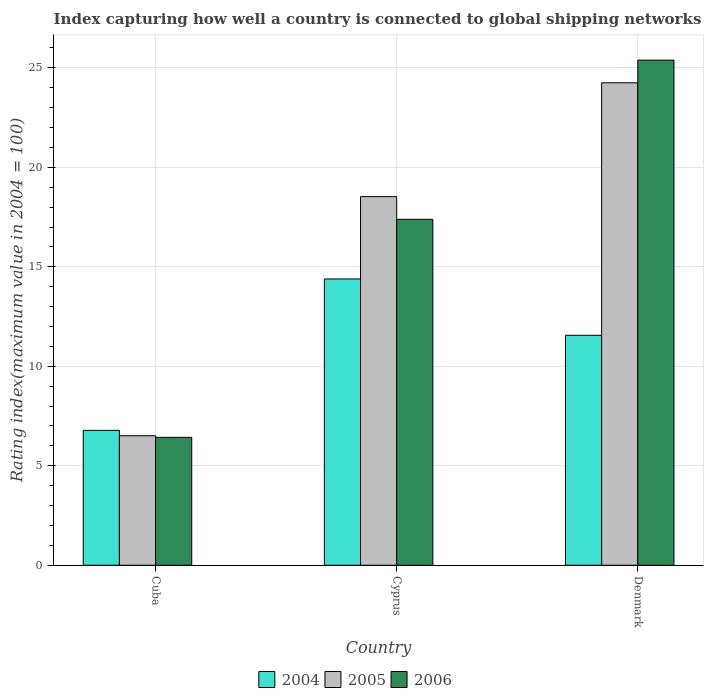How many groups of bars are there?
Provide a short and direct response. 3. How many bars are there on the 3rd tick from the left?
Give a very brief answer. 3. What is the label of the 2nd group of bars from the left?
Make the answer very short. Cyprus. What is the rating index in 2004 in Denmark?
Make the answer very short. 11.56. Across all countries, what is the maximum rating index in 2004?
Keep it short and to the point. 14.39. Across all countries, what is the minimum rating index in 2004?
Ensure brevity in your answer.  6.78. In which country was the rating index in 2006 minimum?
Give a very brief answer. Cuba. What is the total rating index in 2006 in the graph?
Your answer should be very brief. 49.21. What is the difference between the rating index in 2005 in Cuba and that in Cyprus?
Provide a succinct answer. -12.02. What is the difference between the rating index in 2006 in Cuba and the rating index in 2005 in Cyprus?
Your response must be concise. -12.1. What is the average rating index in 2005 per country?
Offer a terse response. 16.43. What is the difference between the rating index of/in 2004 and rating index of/in 2006 in Cuba?
Your answer should be very brief. 0.35. What is the ratio of the rating index in 2004 in Cuba to that in Denmark?
Make the answer very short. 0.59. Is the difference between the rating index in 2004 in Cyprus and Denmark greater than the difference between the rating index in 2006 in Cyprus and Denmark?
Keep it short and to the point. Yes. What is the difference between the highest and the second highest rating index in 2005?
Ensure brevity in your answer.  5.72. What is the difference between the highest and the lowest rating index in 2006?
Offer a very short reply. 18.96. In how many countries, is the rating index in 2006 greater than the average rating index in 2006 taken over all countries?
Ensure brevity in your answer.  2. Is the sum of the rating index in 2004 in Cuba and Denmark greater than the maximum rating index in 2006 across all countries?
Your answer should be very brief. No. What does the 1st bar from the right in Denmark represents?
Make the answer very short. 2006. How many bars are there?
Offer a terse response. 9. Are the values on the major ticks of Y-axis written in scientific E-notation?
Keep it short and to the point. No. Does the graph contain any zero values?
Ensure brevity in your answer.  No. Does the graph contain grids?
Give a very brief answer. Yes. Where does the legend appear in the graph?
Provide a succinct answer. Bottom center. How many legend labels are there?
Your response must be concise. 3. How are the legend labels stacked?
Make the answer very short. Horizontal. What is the title of the graph?
Your response must be concise. Index capturing how well a country is connected to global shipping networks. Does "1963" appear as one of the legend labels in the graph?
Make the answer very short. No. What is the label or title of the X-axis?
Your response must be concise. Country. What is the label or title of the Y-axis?
Make the answer very short. Rating index(maximum value in 2004 = 100). What is the Rating index(maximum value in 2004 = 100) in 2004 in Cuba?
Your answer should be very brief. 6.78. What is the Rating index(maximum value in 2004 = 100) in 2005 in Cuba?
Offer a terse response. 6.51. What is the Rating index(maximum value in 2004 = 100) of 2006 in Cuba?
Your answer should be very brief. 6.43. What is the Rating index(maximum value in 2004 = 100) of 2004 in Cyprus?
Your answer should be compact. 14.39. What is the Rating index(maximum value in 2004 = 100) in 2005 in Cyprus?
Your answer should be very brief. 18.53. What is the Rating index(maximum value in 2004 = 100) in 2006 in Cyprus?
Your response must be concise. 17.39. What is the Rating index(maximum value in 2004 = 100) in 2004 in Denmark?
Your answer should be very brief. 11.56. What is the Rating index(maximum value in 2004 = 100) in 2005 in Denmark?
Make the answer very short. 24.25. What is the Rating index(maximum value in 2004 = 100) in 2006 in Denmark?
Your response must be concise. 25.39. Across all countries, what is the maximum Rating index(maximum value in 2004 = 100) in 2004?
Keep it short and to the point. 14.39. Across all countries, what is the maximum Rating index(maximum value in 2004 = 100) of 2005?
Give a very brief answer. 24.25. Across all countries, what is the maximum Rating index(maximum value in 2004 = 100) in 2006?
Your answer should be compact. 25.39. Across all countries, what is the minimum Rating index(maximum value in 2004 = 100) of 2004?
Your response must be concise. 6.78. Across all countries, what is the minimum Rating index(maximum value in 2004 = 100) in 2005?
Your response must be concise. 6.51. Across all countries, what is the minimum Rating index(maximum value in 2004 = 100) of 2006?
Your answer should be compact. 6.43. What is the total Rating index(maximum value in 2004 = 100) of 2004 in the graph?
Offer a very short reply. 32.73. What is the total Rating index(maximum value in 2004 = 100) of 2005 in the graph?
Offer a very short reply. 49.29. What is the total Rating index(maximum value in 2004 = 100) in 2006 in the graph?
Your answer should be very brief. 49.21. What is the difference between the Rating index(maximum value in 2004 = 100) of 2004 in Cuba and that in Cyprus?
Offer a terse response. -7.61. What is the difference between the Rating index(maximum value in 2004 = 100) of 2005 in Cuba and that in Cyprus?
Provide a short and direct response. -12.02. What is the difference between the Rating index(maximum value in 2004 = 100) in 2006 in Cuba and that in Cyprus?
Provide a succinct answer. -10.96. What is the difference between the Rating index(maximum value in 2004 = 100) of 2004 in Cuba and that in Denmark?
Provide a succinct answer. -4.78. What is the difference between the Rating index(maximum value in 2004 = 100) in 2005 in Cuba and that in Denmark?
Provide a short and direct response. -17.74. What is the difference between the Rating index(maximum value in 2004 = 100) of 2006 in Cuba and that in Denmark?
Provide a succinct answer. -18.96. What is the difference between the Rating index(maximum value in 2004 = 100) of 2004 in Cyprus and that in Denmark?
Make the answer very short. 2.83. What is the difference between the Rating index(maximum value in 2004 = 100) in 2005 in Cyprus and that in Denmark?
Provide a short and direct response. -5.72. What is the difference between the Rating index(maximum value in 2004 = 100) in 2004 in Cuba and the Rating index(maximum value in 2004 = 100) in 2005 in Cyprus?
Keep it short and to the point. -11.75. What is the difference between the Rating index(maximum value in 2004 = 100) in 2004 in Cuba and the Rating index(maximum value in 2004 = 100) in 2006 in Cyprus?
Your answer should be compact. -10.61. What is the difference between the Rating index(maximum value in 2004 = 100) in 2005 in Cuba and the Rating index(maximum value in 2004 = 100) in 2006 in Cyprus?
Keep it short and to the point. -10.88. What is the difference between the Rating index(maximum value in 2004 = 100) in 2004 in Cuba and the Rating index(maximum value in 2004 = 100) in 2005 in Denmark?
Give a very brief answer. -17.47. What is the difference between the Rating index(maximum value in 2004 = 100) in 2004 in Cuba and the Rating index(maximum value in 2004 = 100) in 2006 in Denmark?
Give a very brief answer. -18.61. What is the difference between the Rating index(maximum value in 2004 = 100) in 2005 in Cuba and the Rating index(maximum value in 2004 = 100) in 2006 in Denmark?
Give a very brief answer. -18.88. What is the difference between the Rating index(maximum value in 2004 = 100) in 2004 in Cyprus and the Rating index(maximum value in 2004 = 100) in 2005 in Denmark?
Keep it short and to the point. -9.86. What is the difference between the Rating index(maximum value in 2004 = 100) of 2005 in Cyprus and the Rating index(maximum value in 2004 = 100) of 2006 in Denmark?
Your response must be concise. -6.86. What is the average Rating index(maximum value in 2004 = 100) in 2004 per country?
Ensure brevity in your answer.  10.91. What is the average Rating index(maximum value in 2004 = 100) of 2005 per country?
Your response must be concise. 16.43. What is the average Rating index(maximum value in 2004 = 100) of 2006 per country?
Give a very brief answer. 16.4. What is the difference between the Rating index(maximum value in 2004 = 100) in 2004 and Rating index(maximum value in 2004 = 100) in 2005 in Cuba?
Keep it short and to the point. 0.27. What is the difference between the Rating index(maximum value in 2004 = 100) of 2004 and Rating index(maximum value in 2004 = 100) of 2006 in Cuba?
Your answer should be compact. 0.35. What is the difference between the Rating index(maximum value in 2004 = 100) in 2005 and Rating index(maximum value in 2004 = 100) in 2006 in Cuba?
Give a very brief answer. 0.08. What is the difference between the Rating index(maximum value in 2004 = 100) of 2004 and Rating index(maximum value in 2004 = 100) of 2005 in Cyprus?
Offer a terse response. -4.14. What is the difference between the Rating index(maximum value in 2004 = 100) in 2005 and Rating index(maximum value in 2004 = 100) in 2006 in Cyprus?
Offer a very short reply. 1.14. What is the difference between the Rating index(maximum value in 2004 = 100) in 2004 and Rating index(maximum value in 2004 = 100) in 2005 in Denmark?
Make the answer very short. -12.69. What is the difference between the Rating index(maximum value in 2004 = 100) in 2004 and Rating index(maximum value in 2004 = 100) in 2006 in Denmark?
Your answer should be compact. -13.83. What is the difference between the Rating index(maximum value in 2004 = 100) in 2005 and Rating index(maximum value in 2004 = 100) in 2006 in Denmark?
Provide a succinct answer. -1.14. What is the ratio of the Rating index(maximum value in 2004 = 100) of 2004 in Cuba to that in Cyprus?
Provide a short and direct response. 0.47. What is the ratio of the Rating index(maximum value in 2004 = 100) in 2005 in Cuba to that in Cyprus?
Keep it short and to the point. 0.35. What is the ratio of the Rating index(maximum value in 2004 = 100) of 2006 in Cuba to that in Cyprus?
Your response must be concise. 0.37. What is the ratio of the Rating index(maximum value in 2004 = 100) in 2004 in Cuba to that in Denmark?
Your answer should be very brief. 0.59. What is the ratio of the Rating index(maximum value in 2004 = 100) in 2005 in Cuba to that in Denmark?
Offer a very short reply. 0.27. What is the ratio of the Rating index(maximum value in 2004 = 100) in 2006 in Cuba to that in Denmark?
Offer a terse response. 0.25. What is the ratio of the Rating index(maximum value in 2004 = 100) of 2004 in Cyprus to that in Denmark?
Your answer should be very brief. 1.24. What is the ratio of the Rating index(maximum value in 2004 = 100) in 2005 in Cyprus to that in Denmark?
Offer a very short reply. 0.76. What is the ratio of the Rating index(maximum value in 2004 = 100) in 2006 in Cyprus to that in Denmark?
Your response must be concise. 0.68. What is the difference between the highest and the second highest Rating index(maximum value in 2004 = 100) in 2004?
Provide a short and direct response. 2.83. What is the difference between the highest and the second highest Rating index(maximum value in 2004 = 100) in 2005?
Provide a succinct answer. 5.72. What is the difference between the highest and the lowest Rating index(maximum value in 2004 = 100) of 2004?
Ensure brevity in your answer.  7.61. What is the difference between the highest and the lowest Rating index(maximum value in 2004 = 100) of 2005?
Make the answer very short. 17.74. What is the difference between the highest and the lowest Rating index(maximum value in 2004 = 100) of 2006?
Make the answer very short. 18.96. 